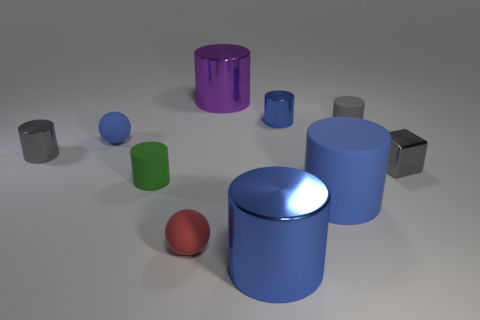Are there any gray cylinders of the same size as the blue ball?
Give a very brief answer. Yes. What number of things are either large green balls or small spheres?
Offer a terse response. 2. There is a blue cylinder behind the green rubber cylinder; is it the same size as the gray metallic thing that is behind the small gray block?
Provide a short and direct response. Yes. Are there any other things of the same shape as the small red thing?
Ensure brevity in your answer.  Yes. Are there fewer large objects that are behind the small blue sphere than small matte cylinders?
Your answer should be compact. Yes. Do the tiny red object and the small blue matte thing have the same shape?
Provide a succinct answer. Yes. There is a blue metallic object that is in front of the green thing; how big is it?
Offer a very short reply. Large. What is the size of the blue cylinder that is the same material as the blue sphere?
Keep it short and to the point. Large. Is the number of green cylinders less than the number of brown cubes?
Keep it short and to the point. No. There is a purple thing that is the same size as the blue matte cylinder; what is its material?
Your response must be concise. Metal. 